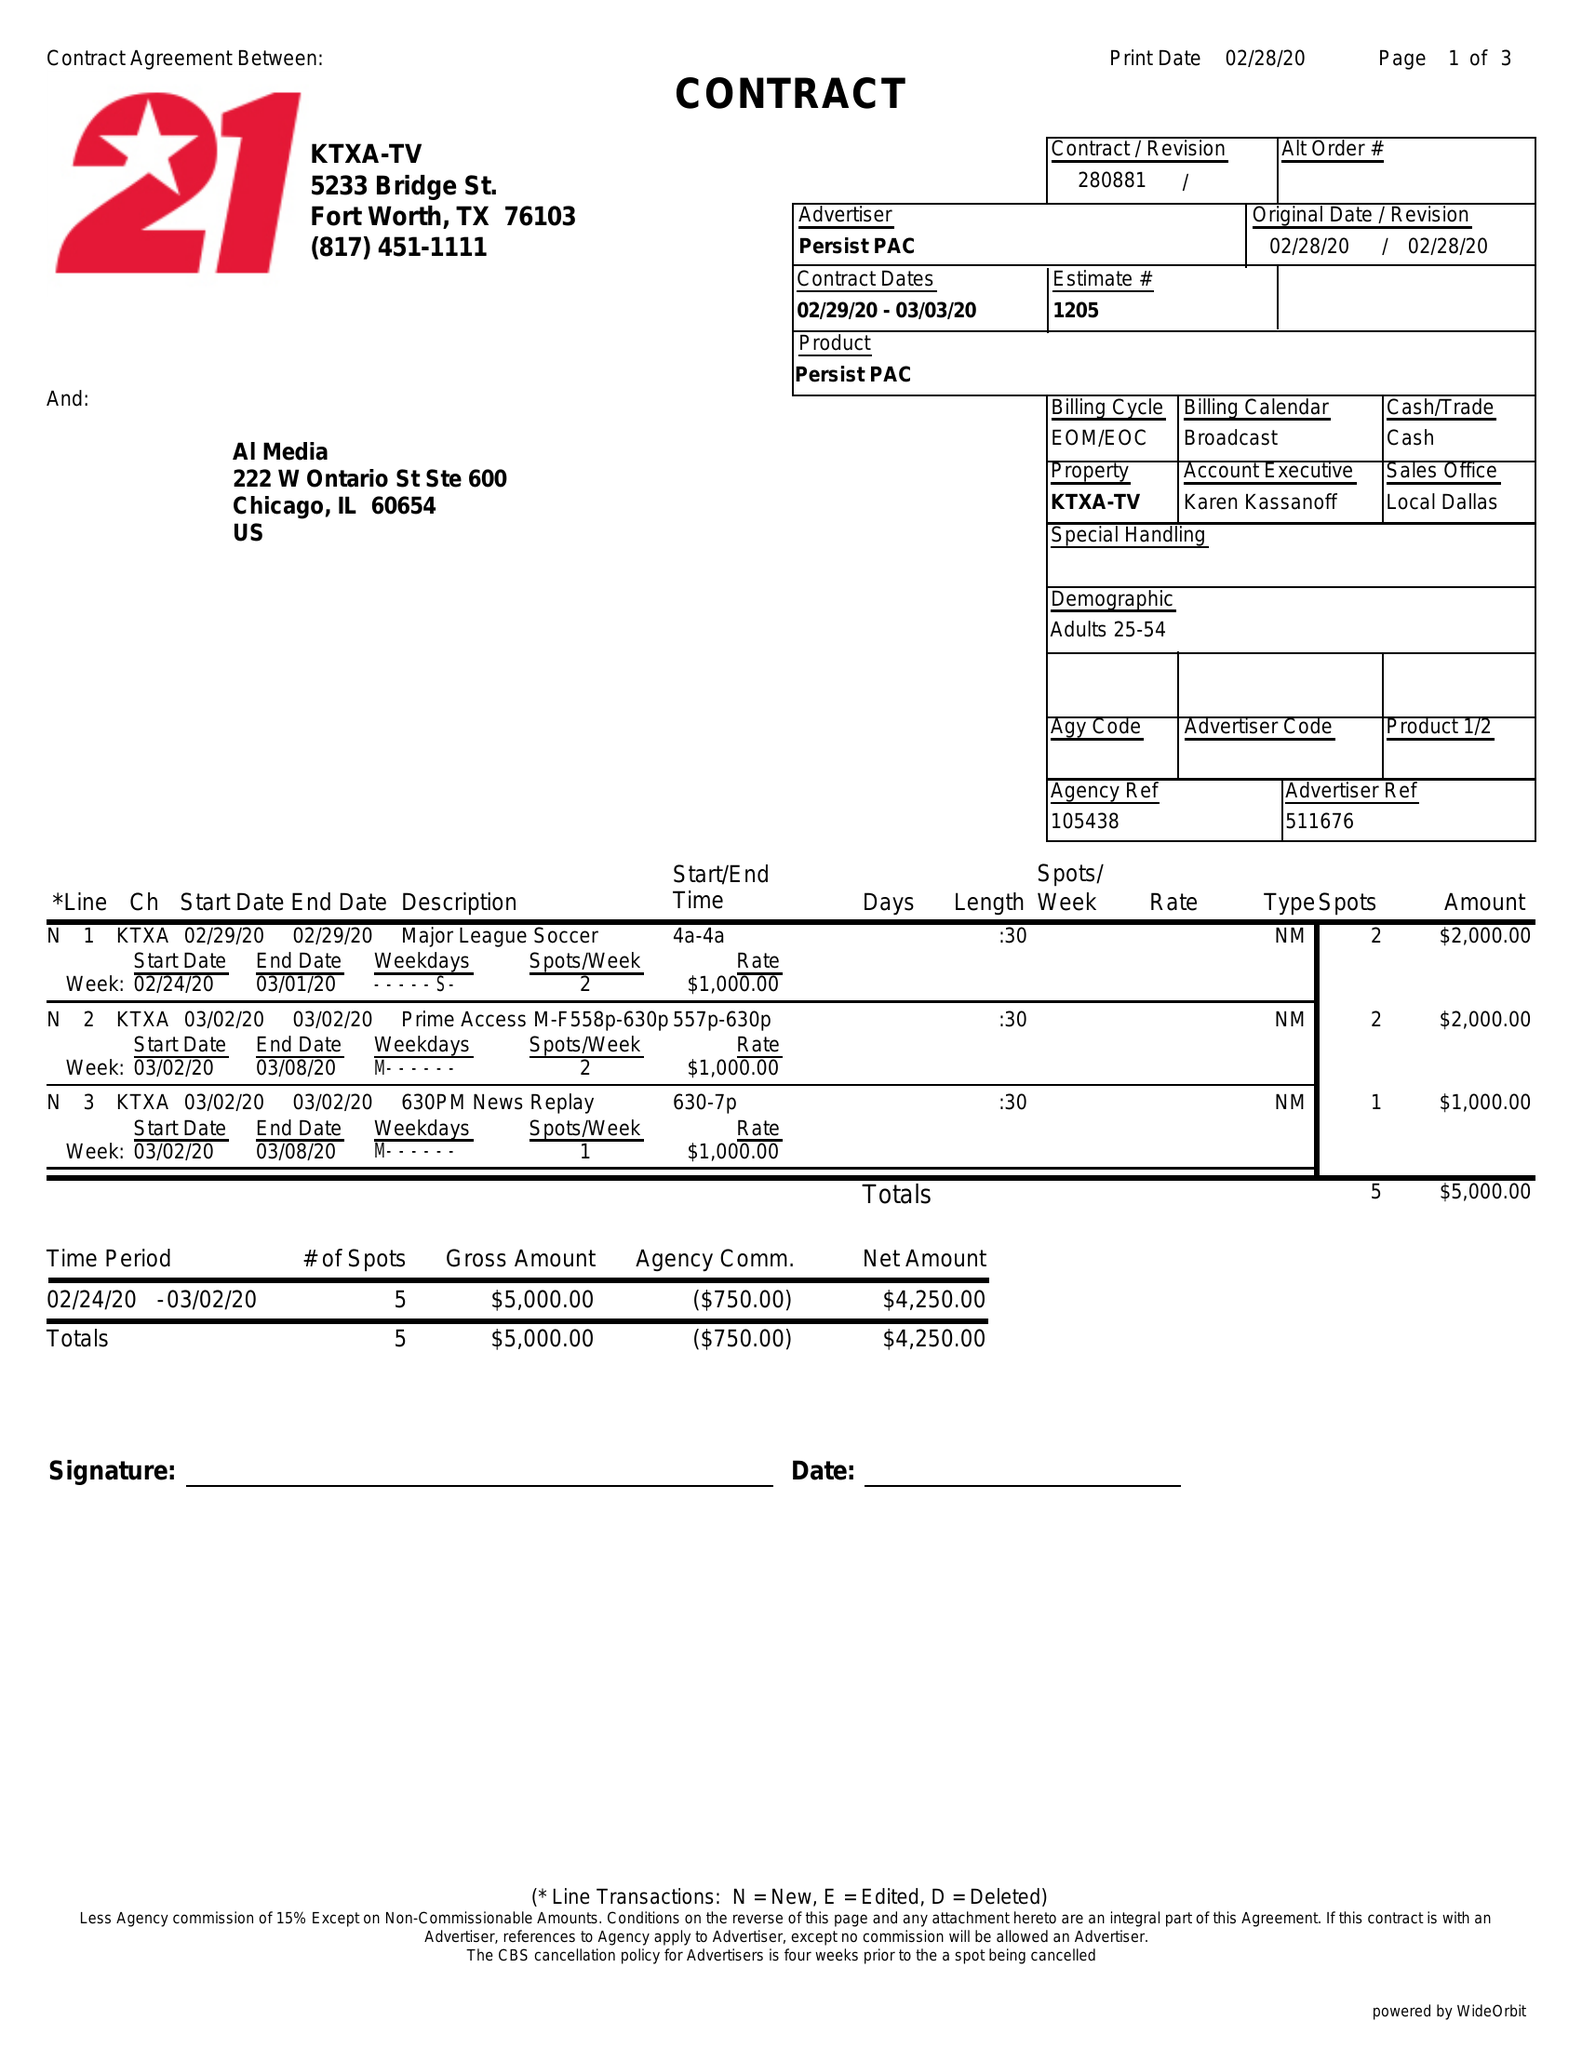What is the value for the flight_to?
Answer the question using a single word or phrase. 03/03/20 